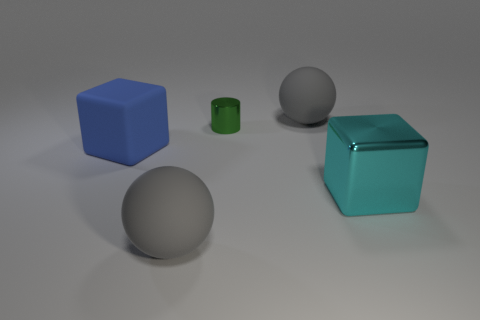The thing that is behind the large cyan block and left of the green metal cylinder is made of what material?
Offer a very short reply. Rubber. The metallic cube has what color?
Your answer should be compact. Cyan. There is a large matte thing in front of the large shiny cube; what is its shape?
Ensure brevity in your answer.  Sphere. There is a gray ball that is in front of the large gray rubber object behind the tiny green metal object; is there a gray rubber thing on the right side of it?
Keep it short and to the point. Yes. Is there any other thing that has the same shape as the tiny green metal object?
Your response must be concise. No. Are there any rubber balls?
Keep it short and to the point. Yes. Is the gray ball left of the cylinder made of the same material as the large object behind the large blue rubber cube?
Offer a terse response. Yes. What is the size of the green metallic thing that is behind the large ball on the left side of the large matte sphere on the right side of the metal cylinder?
Your response must be concise. Small. What number of small blue blocks are the same material as the cylinder?
Your response must be concise. 0. Are there fewer metal objects than green matte objects?
Your answer should be very brief. No. 